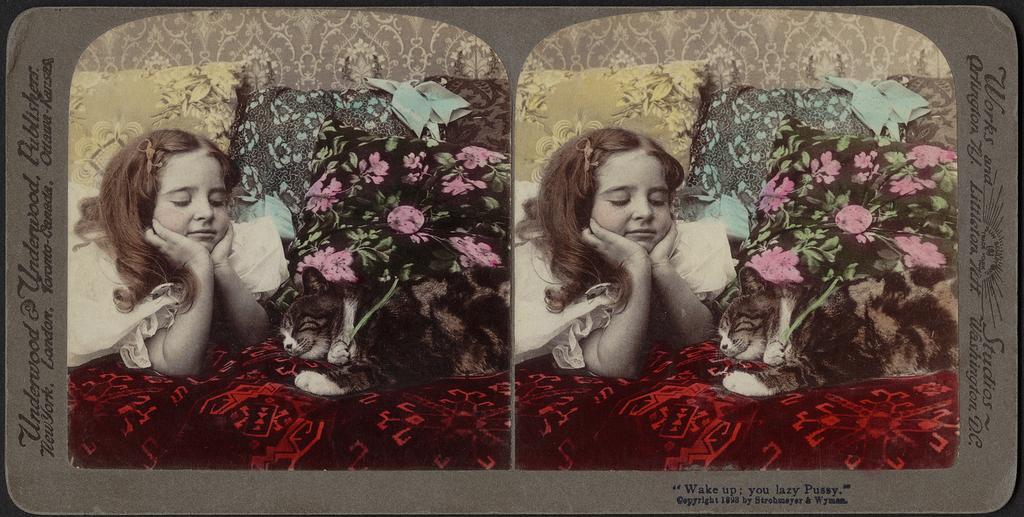Please provide a concise description of this image. This image consists of a card. On which there is a picture of a girl along with a cat and pillows. 